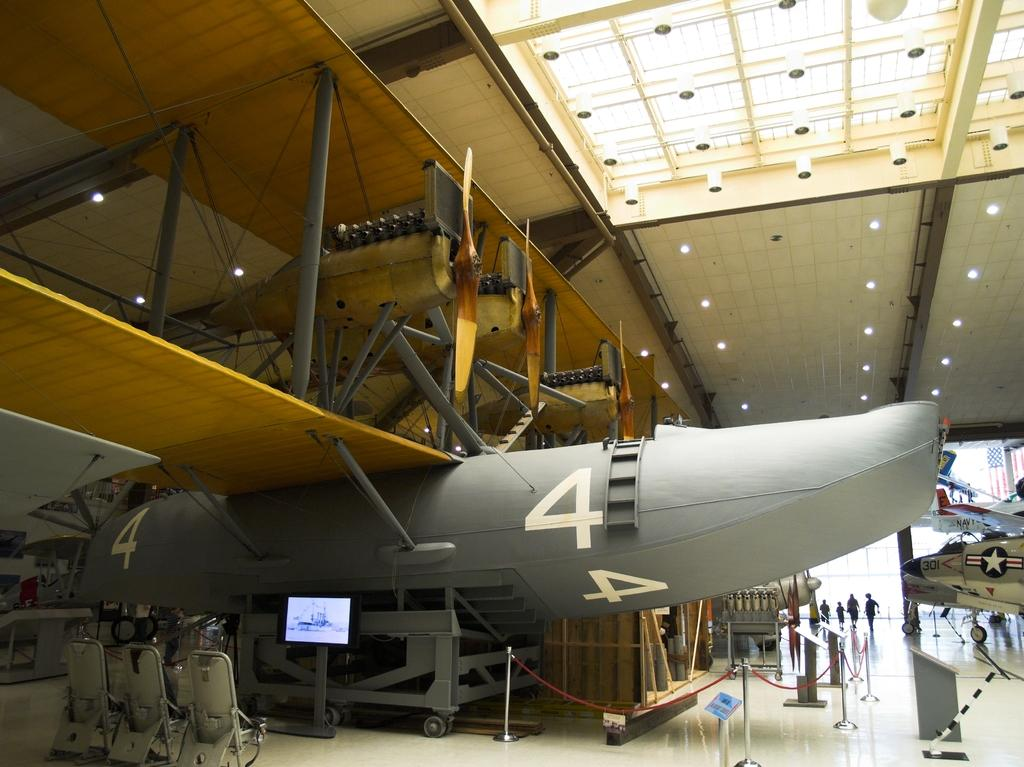<image>
Share a concise interpretation of the image provided. Gray airplane with number four engraved in white. 